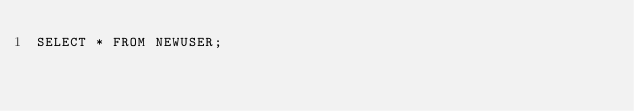<code> <loc_0><loc_0><loc_500><loc_500><_SQL_>SELECT * FROM NEWUSER;</code> 